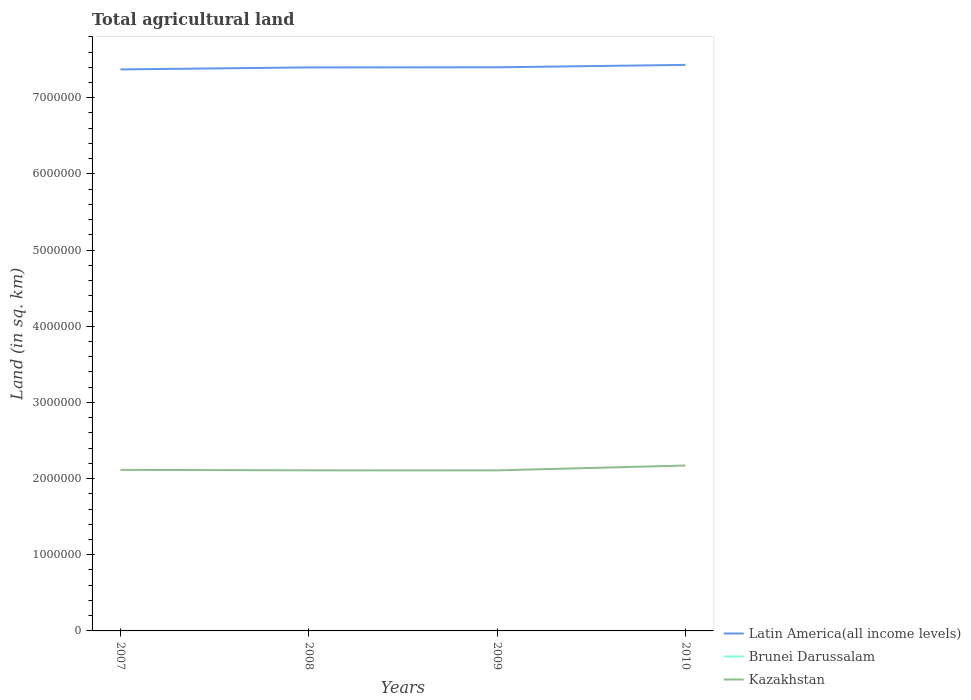How many different coloured lines are there?
Give a very brief answer. 3. Does the line corresponding to Kazakhstan intersect with the line corresponding to Brunei Darussalam?
Give a very brief answer. No. Across all years, what is the maximum total agricultural land in Kazakhstan?
Give a very brief answer. 2.11e+06. In which year was the total agricultural land in Latin America(all income levels) maximum?
Ensure brevity in your answer.  2007. What is the difference between the highest and the second highest total agricultural land in Latin America(all income levels)?
Your response must be concise. 5.97e+04. What is the difference between the highest and the lowest total agricultural land in Kazakhstan?
Keep it short and to the point. 1. Is the total agricultural land in Brunei Darussalam strictly greater than the total agricultural land in Latin America(all income levels) over the years?
Your answer should be very brief. Yes. How many lines are there?
Your answer should be compact. 3. What is the difference between two consecutive major ticks on the Y-axis?
Provide a short and direct response. 1.00e+06. Are the values on the major ticks of Y-axis written in scientific E-notation?
Keep it short and to the point. No. How many legend labels are there?
Your answer should be very brief. 3. How are the legend labels stacked?
Offer a terse response. Vertical. What is the title of the graph?
Make the answer very short. Total agricultural land. Does "Papua New Guinea" appear as one of the legend labels in the graph?
Ensure brevity in your answer.  No. What is the label or title of the X-axis?
Offer a very short reply. Years. What is the label or title of the Y-axis?
Provide a short and direct response. Land (in sq. km). What is the Land (in sq. km) in Latin America(all income levels) in 2007?
Your response must be concise. 7.37e+06. What is the Land (in sq. km) in Brunei Darussalam in 2007?
Offer a terse response. 114. What is the Land (in sq. km) of Kazakhstan in 2007?
Your answer should be compact. 2.11e+06. What is the Land (in sq. km) in Latin America(all income levels) in 2008?
Your answer should be very brief. 7.40e+06. What is the Land (in sq. km) in Brunei Darussalam in 2008?
Your answer should be very brief. 114. What is the Land (in sq. km) in Kazakhstan in 2008?
Provide a succinct answer. 2.11e+06. What is the Land (in sq. km) in Latin America(all income levels) in 2009?
Your answer should be compact. 7.40e+06. What is the Land (in sq. km) of Brunei Darussalam in 2009?
Provide a succinct answer. 134. What is the Land (in sq. km) in Kazakhstan in 2009?
Your answer should be very brief. 2.11e+06. What is the Land (in sq. km) of Latin America(all income levels) in 2010?
Offer a very short reply. 7.43e+06. What is the Land (in sq. km) of Brunei Darussalam in 2010?
Make the answer very short. 134. What is the Land (in sq. km) of Kazakhstan in 2010?
Make the answer very short. 2.17e+06. Across all years, what is the maximum Land (in sq. km) of Latin America(all income levels)?
Make the answer very short. 7.43e+06. Across all years, what is the maximum Land (in sq. km) in Brunei Darussalam?
Provide a short and direct response. 134. Across all years, what is the maximum Land (in sq. km) of Kazakhstan?
Your response must be concise. 2.17e+06. Across all years, what is the minimum Land (in sq. km) of Latin America(all income levels)?
Provide a succinct answer. 7.37e+06. Across all years, what is the minimum Land (in sq. km) of Brunei Darussalam?
Ensure brevity in your answer.  114. Across all years, what is the minimum Land (in sq. km) of Kazakhstan?
Ensure brevity in your answer.  2.11e+06. What is the total Land (in sq. km) of Latin America(all income levels) in the graph?
Offer a very short reply. 2.96e+07. What is the total Land (in sq. km) in Brunei Darussalam in the graph?
Give a very brief answer. 496. What is the total Land (in sq. km) of Kazakhstan in the graph?
Keep it short and to the point. 8.50e+06. What is the difference between the Land (in sq. km) of Latin America(all income levels) in 2007 and that in 2008?
Give a very brief answer. -2.65e+04. What is the difference between the Land (in sq. km) in Kazakhstan in 2007 and that in 2008?
Provide a short and direct response. 5842. What is the difference between the Land (in sq. km) in Latin America(all income levels) in 2007 and that in 2009?
Your answer should be very brief. -2.79e+04. What is the difference between the Land (in sq. km) of Brunei Darussalam in 2007 and that in 2009?
Give a very brief answer. -20. What is the difference between the Land (in sq. km) in Kazakhstan in 2007 and that in 2009?
Provide a succinct answer. 6523. What is the difference between the Land (in sq. km) of Latin America(all income levels) in 2007 and that in 2010?
Keep it short and to the point. -5.97e+04. What is the difference between the Land (in sq. km) in Brunei Darussalam in 2007 and that in 2010?
Your response must be concise. -20. What is the difference between the Land (in sq. km) of Kazakhstan in 2007 and that in 2010?
Offer a very short reply. -5.73e+04. What is the difference between the Land (in sq. km) in Latin America(all income levels) in 2008 and that in 2009?
Offer a very short reply. -1397.7. What is the difference between the Land (in sq. km) in Brunei Darussalam in 2008 and that in 2009?
Make the answer very short. -20. What is the difference between the Land (in sq. km) in Kazakhstan in 2008 and that in 2009?
Ensure brevity in your answer.  681. What is the difference between the Land (in sq. km) of Latin America(all income levels) in 2008 and that in 2010?
Make the answer very short. -3.33e+04. What is the difference between the Land (in sq. km) in Kazakhstan in 2008 and that in 2010?
Give a very brief answer. -6.31e+04. What is the difference between the Land (in sq. km) of Latin America(all income levels) in 2009 and that in 2010?
Make the answer very short. -3.19e+04. What is the difference between the Land (in sq. km) in Brunei Darussalam in 2009 and that in 2010?
Keep it short and to the point. 0. What is the difference between the Land (in sq. km) in Kazakhstan in 2009 and that in 2010?
Your answer should be compact. -6.38e+04. What is the difference between the Land (in sq. km) of Latin America(all income levels) in 2007 and the Land (in sq. km) of Brunei Darussalam in 2008?
Your response must be concise. 7.37e+06. What is the difference between the Land (in sq. km) of Latin America(all income levels) in 2007 and the Land (in sq. km) of Kazakhstan in 2008?
Your response must be concise. 5.26e+06. What is the difference between the Land (in sq. km) of Brunei Darussalam in 2007 and the Land (in sq. km) of Kazakhstan in 2008?
Offer a terse response. -2.11e+06. What is the difference between the Land (in sq. km) in Latin America(all income levels) in 2007 and the Land (in sq. km) in Brunei Darussalam in 2009?
Make the answer very short. 7.37e+06. What is the difference between the Land (in sq. km) of Latin America(all income levels) in 2007 and the Land (in sq. km) of Kazakhstan in 2009?
Offer a terse response. 5.26e+06. What is the difference between the Land (in sq. km) in Brunei Darussalam in 2007 and the Land (in sq. km) in Kazakhstan in 2009?
Keep it short and to the point. -2.11e+06. What is the difference between the Land (in sq. km) in Latin America(all income levels) in 2007 and the Land (in sq. km) in Brunei Darussalam in 2010?
Make the answer very short. 7.37e+06. What is the difference between the Land (in sq. km) of Latin America(all income levels) in 2007 and the Land (in sq. km) of Kazakhstan in 2010?
Provide a short and direct response. 5.20e+06. What is the difference between the Land (in sq. km) of Brunei Darussalam in 2007 and the Land (in sq. km) of Kazakhstan in 2010?
Your answer should be compact. -2.17e+06. What is the difference between the Land (in sq. km) in Latin America(all income levels) in 2008 and the Land (in sq. km) in Brunei Darussalam in 2009?
Your answer should be compact. 7.40e+06. What is the difference between the Land (in sq. km) in Latin America(all income levels) in 2008 and the Land (in sq. km) in Kazakhstan in 2009?
Keep it short and to the point. 5.29e+06. What is the difference between the Land (in sq. km) of Brunei Darussalam in 2008 and the Land (in sq. km) of Kazakhstan in 2009?
Keep it short and to the point. -2.11e+06. What is the difference between the Land (in sq. km) of Latin America(all income levels) in 2008 and the Land (in sq. km) of Brunei Darussalam in 2010?
Ensure brevity in your answer.  7.40e+06. What is the difference between the Land (in sq. km) of Latin America(all income levels) in 2008 and the Land (in sq. km) of Kazakhstan in 2010?
Provide a succinct answer. 5.23e+06. What is the difference between the Land (in sq. km) of Brunei Darussalam in 2008 and the Land (in sq. km) of Kazakhstan in 2010?
Provide a succinct answer. -2.17e+06. What is the difference between the Land (in sq. km) of Latin America(all income levels) in 2009 and the Land (in sq. km) of Brunei Darussalam in 2010?
Ensure brevity in your answer.  7.40e+06. What is the difference between the Land (in sq. km) in Latin America(all income levels) in 2009 and the Land (in sq. km) in Kazakhstan in 2010?
Ensure brevity in your answer.  5.23e+06. What is the difference between the Land (in sq. km) of Brunei Darussalam in 2009 and the Land (in sq. km) of Kazakhstan in 2010?
Offer a terse response. -2.17e+06. What is the average Land (in sq. km) in Latin America(all income levels) per year?
Offer a terse response. 7.40e+06. What is the average Land (in sq. km) of Brunei Darussalam per year?
Your response must be concise. 124. What is the average Land (in sq. km) of Kazakhstan per year?
Give a very brief answer. 2.13e+06. In the year 2007, what is the difference between the Land (in sq. km) of Latin America(all income levels) and Land (in sq. km) of Brunei Darussalam?
Your answer should be very brief. 7.37e+06. In the year 2007, what is the difference between the Land (in sq. km) in Latin America(all income levels) and Land (in sq. km) in Kazakhstan?
Your response must be concise. 5.26e+06. In the year 2007, what is the difference between the Land (in sq. km) in Brunei Darussalam and Land (in sq. km) in Kazakhstan?
Offer a terse response. -2.11e+06. In the year 2008, what is the difference between the Land (in sq. km) of Latin America(all income levels) and Land (in sq. km) of Brunei Darussalam?
Your answer should be compact. 7.40e+06. In the year 2008, what is the difference between the Land (in sq. km) in Latin America(all income levels) and Land (in sq. km) in Kazakhstan?
Give a very brief answer. 5.29e+06. In the year 2008, what is the difference between the Land (in sq. km) in Brunei Darussalam and Land (in sq. km) in Kazakhstan?
Provide a short and direct response. -2.11e+06. In the year 2009, what is the difference between the Land (in sq. km) of Latin America(all income levels) and Land (in sq. km) of Brunei Darussalam?
Provide a succinct answer. 7.40e+06. In the year 2009, what is the difference between the Land (in sq. km) of Latin America(all income levels) and Land (in sq. km) of Kazakhstan?
Make the answer very short. 5.29e+06. In the year 2009, what is the difference between the Land (in sq. km) of Brunei Darussalam and Land (in sq. km) of Kazakhstan?
Provide a short and direct response. -2.11e+06. In the year 2010, what is the difference between the Land (in sq. km) of Latin America(all income levels) and Land (in sq. km) of Brunei Darussalam?
Ensure brevity in your answer.  7.43e+06. In the year 2010, what is the difference between the Land (in sq. km) of Latin America(all income levels) and Land (in sq. km) of Kazakhstan?
Your answer should be compact. 5.26e+06. In the year 2010, what is the difference between the Land (in sq. km) of Brunei Darussalam and Land (in sq. km) of Kazakhstan?
Offer a terse response. -2.17e+06. What is the ratio of the Land (in sq. km) of Brunei Darussalam in 2007 to that in 2008?
Make the answer very short. 1. What is the ratio of the Land (in sq. km) in Kazakhstan in 2007 to that in 2008?
Your answer should be very brief. 1. What is the ratio of the Land (in sq. km) of Brunei Darussalam in 2007 to that in 2009?
Keep it short and to the point. 0.85. What is the ratio of the Land (in sq. km) of Latin America(all income levels) in 2007 to that in 2010?
Offer a very short reply. 0.99. What is the ratio of the Land (in sq. km) in Brunei Darussalam in 2007 to that in 2010?
Your answer should be compact. 0.85. What is the ratio of the Land (in sq. km) of Kazakhstan in 2007 to that in 2010?
Provide a succinct answer. 0.97. What is the ratio of the Land (in sq. km) in Latin America(all income levels) in 2008 to that in 2009?
Provide a succinct answer. 1. What is the ratio of the Land (in sq. km) in Brunei Darussalam in 2008 to that in 2009?
Offer a terse response. 0.85. What is the ratio of the Land (in sq. km) in Kazakhstan in 2008 to that in 2009?
Ensure brevity in your answer.  1. What is the ratio of the Land (in sq. km) in Brunei Darussalam in 2008 to that in 2010?
Ensure brevity in your answer.  0.85. What is the ratio of the Land (in sq. km) of Kazakhstan in 2008 to that in 2010?
Offer a very short reply. 0.97. What is the ratio of the Land (in sq. km) of Kazakhstan in 2009 to that in 2010?
Make the answer very short. 0.97. What is the difference between the highest and the second highest Land (in sq. km) in Latin America(all income levels)?
Offer a terse response. 3.19e+04. What is the difference between the highest and the second highest Land (in sq. km) in Kazakhstan?
Provide a succinct answer. 5.73e+04. What is the difference between the highest and the lowest Land (in sq. km) in Latin America(all income levels)?
Provide a succinct answer. 5.97e+04. What is the difference between the highest and the lowest Land (in sq. km) in Kazakhstan?
Your answer should be very brief. 6.38e+04. 